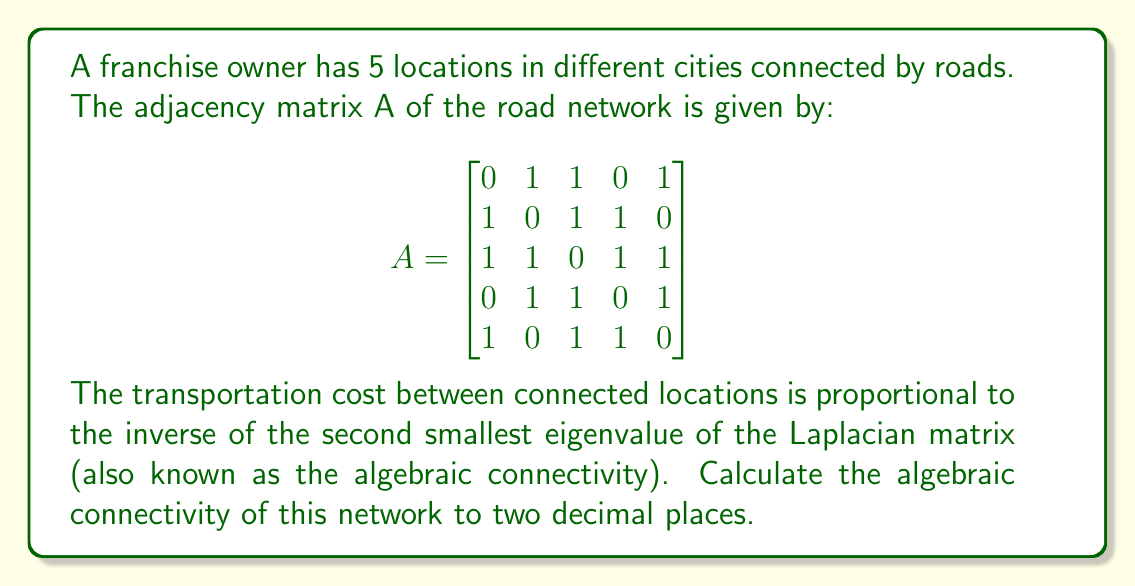Solve this math problem. To solve this problem, we'll follow these steps:

1) First, we need to calculate the Laplacian matrix L from the adjacency matrix A.
   L = D - A, where D is the degree matrix.

2) The degree matrix D is a diagonal matrix where each diagonal entry is the sum of the corresponding row in A.

   $$D = \begin{bmatrix}
   3 & 0 & 0 & 0 & 0 \\
   0 & 3 & 0 & 0 & 0 \\
   0 & 0 & 4 & 0 & 0 \\
   0 & 0 & 0 & 3 & 0 \\
   0 & 0 & 0 & 0 & 3
   \end{bmatrix}$$

3) Now we can calculate L:

   $$L = D - A = \begin{bmatrix}
   3 & -1 & -1 & 0 & -1 \\
   -1 & 3 & -1 & -1 & 0 \\
   -1 & -1 & 4 & -1 & -1 \\
   0 & -1 & -1 & 3 & -1 \\
   -1 & 0 & -1 & -1 & 3
   \end{bmatrix}$$

4) We need to find the eigenvalues of L. The characteristic equation is:

   $$det(L - \lambda I) = 0$$

5) Solving this equation (which is a 5th degree polynomial) is complex, so we would typically use numerical methods or software.

6) The eigenvalues of L are approximately:
   0, 1.38, 3, 4, 5.62

7) The algebraic connectivity is the second smallest eigenvalue, which is approximately 1.38.

8) Rounding to two decimal places, we get 1.38.
Answer: 1.38 